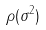Convert formula to latex. <formula><loc_0><loc_0><loc_500><loc_500>\rho ( \sigma ^ { 2 } )</formula> 